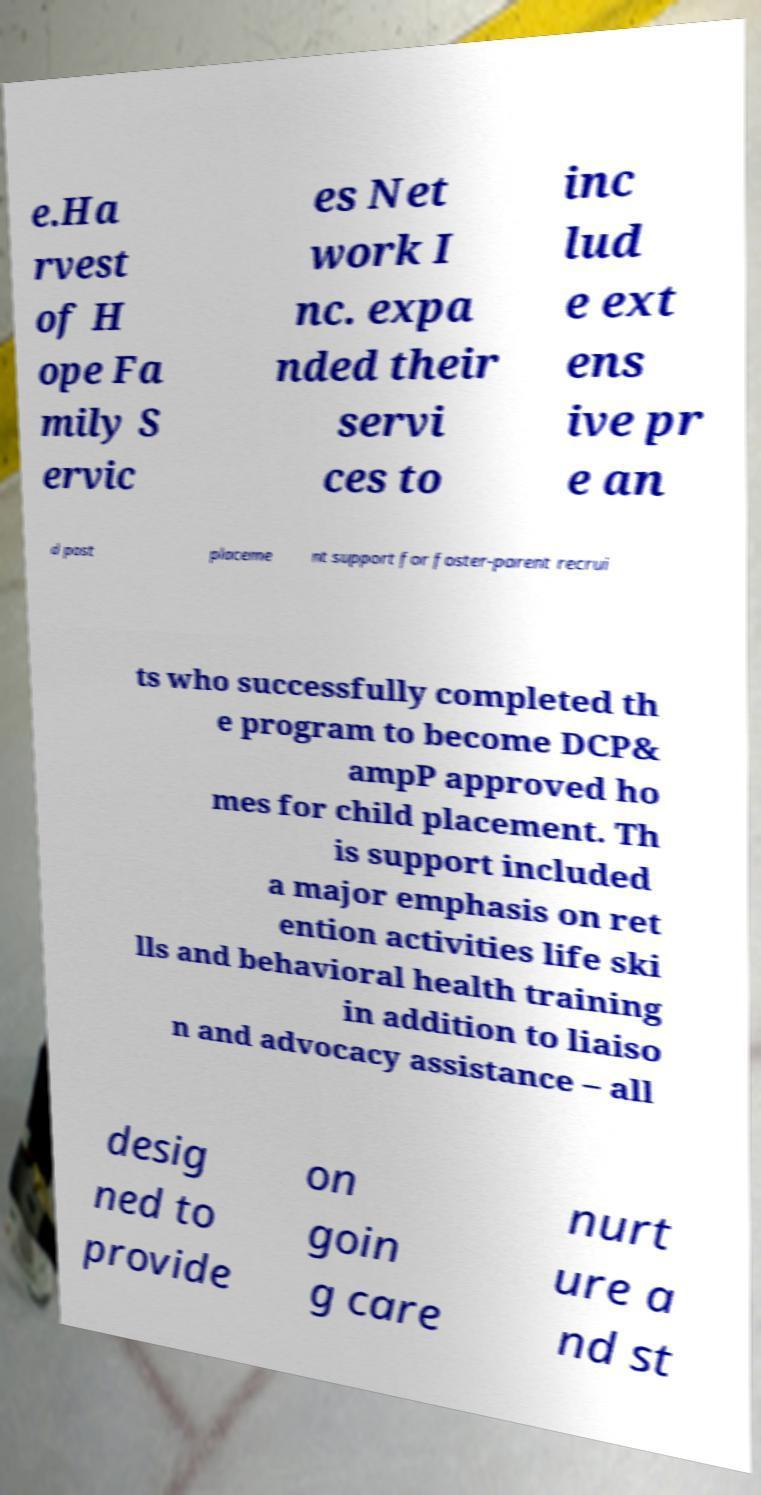Could you assist in decoding the text presented in this image and type it out clearly? e.Ha rvest of H ope Fa mily S ervic es Net work I nc. expa nded their servi ces to inc lud e ext ens ive pr e an d post placeme nt support for foster-parent recrui ts who successfully completed th e program to become DCP& ampP approved ho mes for child placement. Th is support included a major emphasis on ret ention activities life ski lls and behavioral health training in addition to liaiso n and advocacy assistance – all desig ned to provide on goin g care nurt ure a nd st 